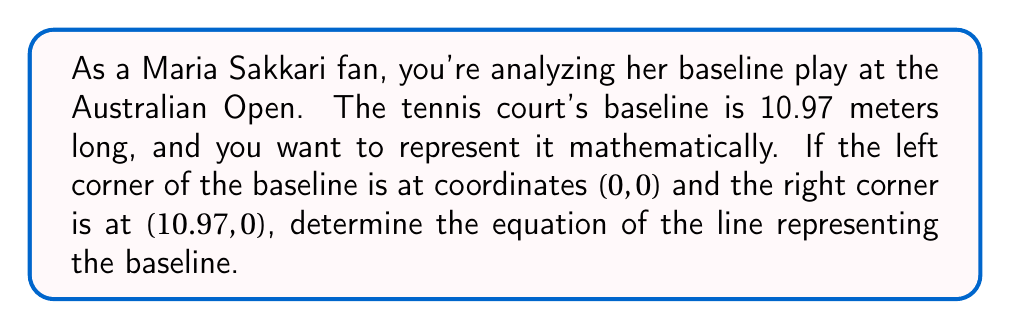Could you help me with this problem? Let's approach this step-by-step:

1) The baseline is a horizontal line, which means its slope is 0.

2) We can use the point-slope form of a line equation:
   $y - y_1 = m(x - x_1)$
   Where $m$ is the slope, and $(x_1, y_1)$ is a point on the line.

3) We know:
   - Slope $m = 0$
   - A point on the line: $(0, 0)$

4) Substituting these into the point-slope form:
   $y - 0 = 0(x - 0)$

5) Simplifying:
   $y = 0$

6) This makes sense because for any $x$ value along the baseline, the $y$ coordinate will always be 0.

7) We can verify this with the right corner point (10.97, 0):
   $0 = 0$ (true for $x = 10.97$)

Therefore, the equation $y = 0$ represents the baseline of the tennis court.
Answer: $y = 0$ 